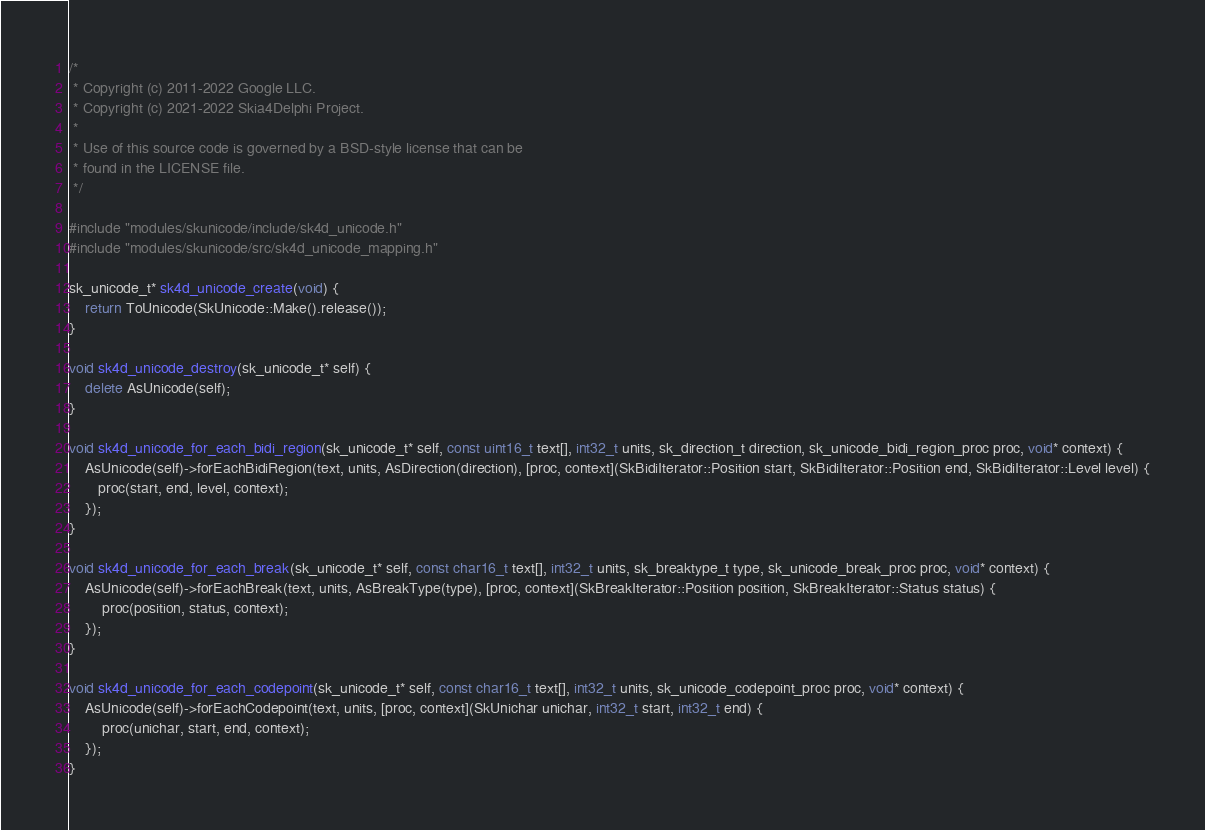<code> <loc_0><loc_0><loc_500><loc_500><_C++_>/*
 * Copyright (c) 2011-2022 Google LLC.
 * Copyright (c) 2021-2022 Skia4Delphi Project.
 *
 * Use of this source code is governed by a BSD-style license that can be
 * found in the LICENSE file.
 */

#include "modules/skunicode/include/sk4d_unicode.h"
#include "modules/skunicode/src/sk4d_unicode_mapping.h"

sk_unicode_t* sk4d_unicode_create(void) {
    return ToUnicode(SkUnicode::Make().release());
}

void sk4d_unicode_destroy(sk_unicode_t* self) {
    delete AsUnicode(self);
}

void sk4d_unicode_for_each_bidi_region(sk_unicode_t* self, const uint16_t text[], int32_t units, sk_direction_t direction, sk_unicode_bidi_region_proc proc, void* context) {
    AsUnicode(self)->forEachBidiRegion(text, units, AsDirection(direction), [proc, context](SkBidiIterator::Position start, SkBidiIterator::Position end, SkBidiIterator::Level level) {
       proc(start, end, level, context);
    });
}

void sk4d_unicode_for_each_break(sk_unicode_t* self, const char16_t text[], int32_t units, sk_breaktype_t type, sk_unicode_break_proc proc, void* context) {
    AsUnicode(self)->forEachBreak(text, units, AsBreakType(type), [proc, context](SkBreakIterator::Position position, SkBreakIterator::Status status) { 
        proc(position, status, context);
    });
}

void sk4d_unicode_for_each_codepoint(sk_unicode_t* self, const char16_t text[], int32_t units, sk_unicode_codepoint_proc proc, void* context) {
    AsUnicode(self)->forEachCodepoint(text, units, [proc, context](SkUnichar unichar, int32_t start, int32_t end) {
        proc(unichar, start, end, context);
    });
}

</code> 